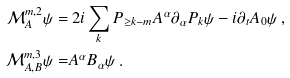<formula> <loc_0><loc_0><loc_500><loc_500>\mathcal { M } _ { A } ^ { m , 2 } \psi = & \ 2 i \sum _ { k } P _ { \geq k - m } A ^ { \alpha } \partial _ { \alpha } P _ { k } \psi - i \partial _ { t } A _ { 0 } \psi \ , \\ \mathcal { M } _ { A , B } ^ { m , 3 } \psi = & A ^ { \alpha } B _ { \alpha } \psi \ .</formula> 